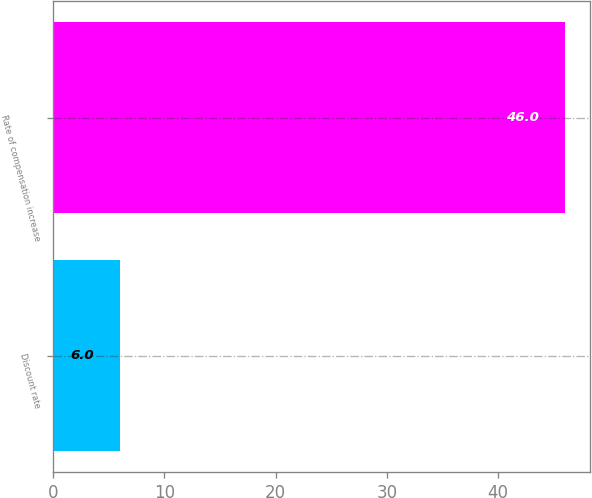Convert chart. <chart><loc_0><loc_0><loc_500><loc_500><bar_chart><fcel>Discount rate<fcel>Rate of compensation increase<nl><fcel>6<fcel>46<nl></chart> 